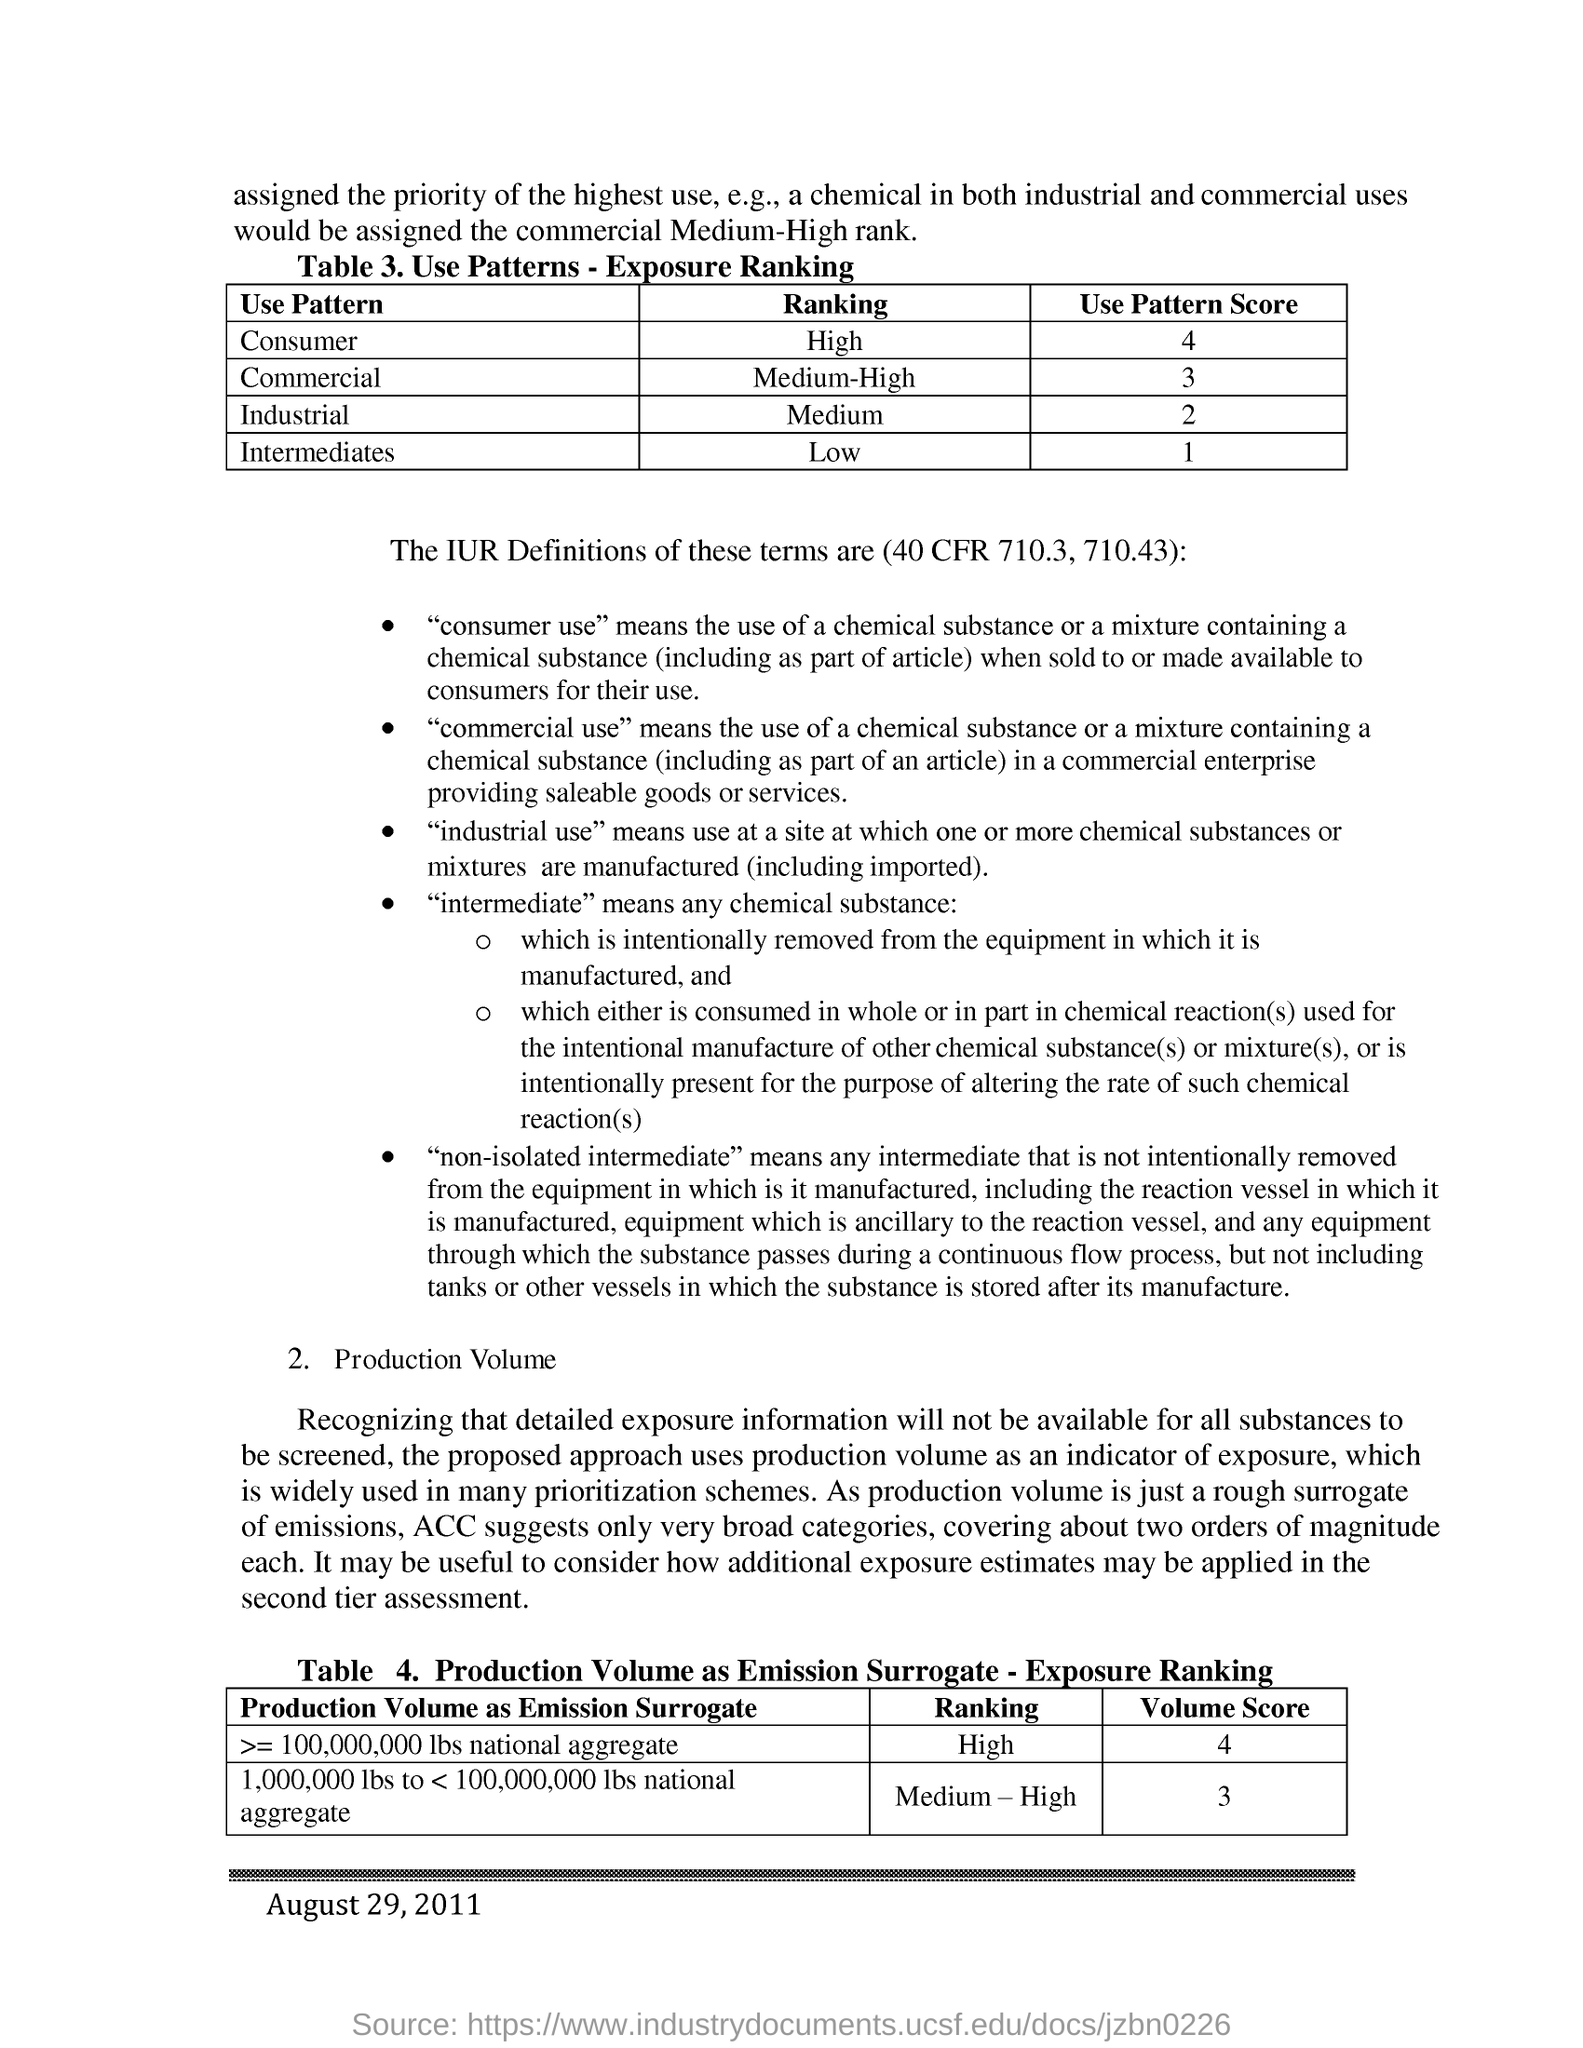What is the use pattern ranking of consumer?
Offer a terse response. High. What is the use pattern score of consumer?
Your answer should be compact. 4. What is the use pattern score of industrial?
Your answer should be very brief. 2. What is the use pattern ranking of commercial?
Your answer should be compact. Medium-High. What is the use pattern ranking of intermediates?
Your answer should be compact. Low. 